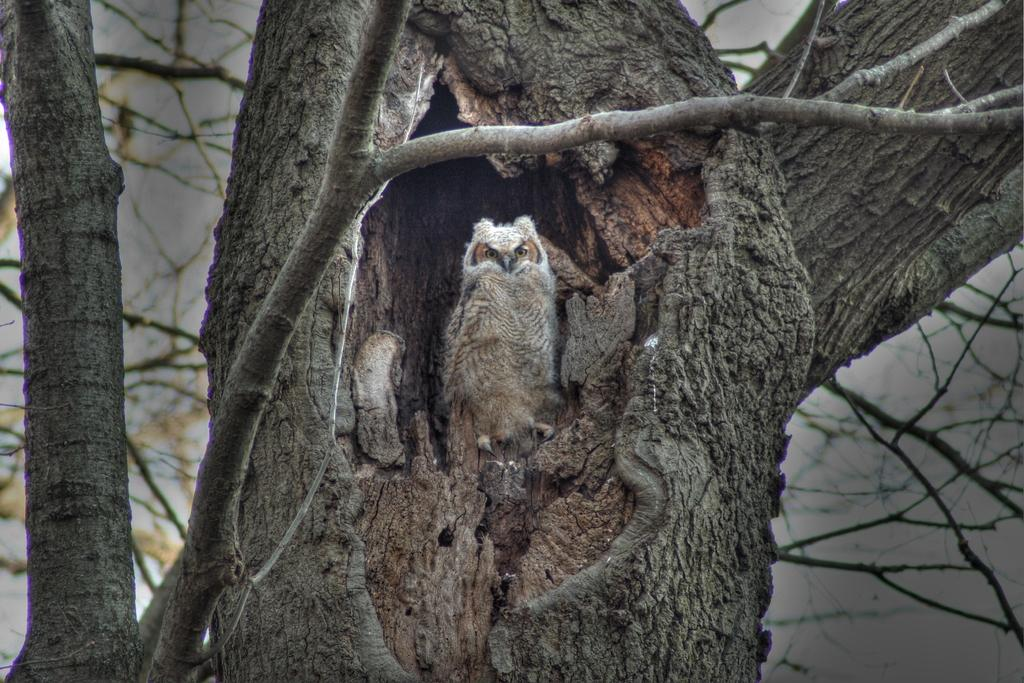What type of animal is in the image? There is an owl in the image. Where is the owl located? The owl is on a tree. What part of the tree can be seen in the image? There is a tree trunk visible in the image. How many branches are visible on the tree? There are three branches on the tree. What is the purpose of the vest in the image? There is no vest present in the image. 